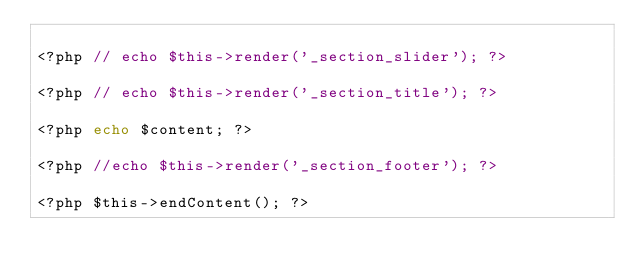<code> <loc_0><loc_0><loc_500><loc_500><_PHP_>
<?php // echo $this->render('_section_slider'); ?>

<?php // echo $this->render('_section_title'); ?>

<?php echo $content; ?>

<?php //echo $this->render('_section_footer'); ?>

<?php $this->endContent(); ?>
</code> 